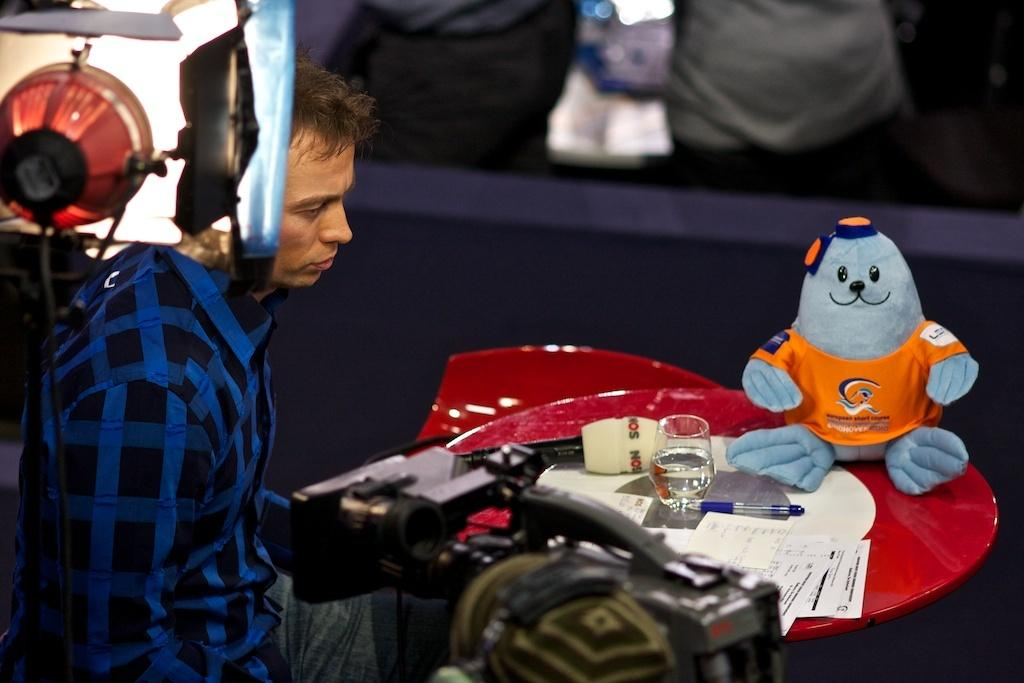What is the man in the image doing? The man is sitting in front of a table. What objects are on the table in the image? There is a microphone, a glass, papers, and a doll on the table. Can you describe the lighting in the image? There is a light on the left side of the image. How many rabbits are hiding under the table in the image? There are no rabbits present in the image. What type of alarm is going off in the image? There is no alarm present in the image. 